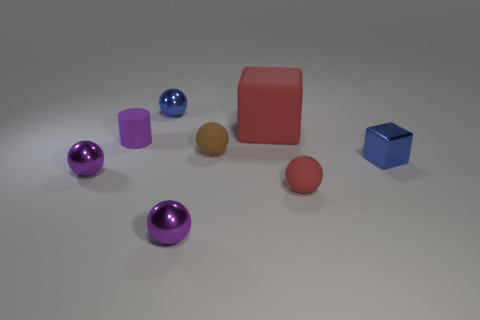What number of red rubber things are the same size as the brown matte thing?
Provide a succinct answer. 1. What material is the red object that is in front of the thing left of the cylinder?
Make the answer very short. Rubber. The purple metallic object that is right of the tiny matte thing that is to the left of the small blue thing left of the tiny metal block is what shape?
Give a very brief answer. Sphere. Do the tiny blue object that is to the left of the red ball and the red thing to the right of the large thing have the same shape?
Keep it short and to the point. Yes. How many other objects are there of the same material as the brown thing?
Provide a short and direct response. 3. What shape is the small brown object that is the same material as the tiny cylinder?
Provide a short and direct response. Sphere. Do the brown sphere and the purple matte cylinder have the same size?
Offer a terse response. Yes. There is a purple object right of the blue shiny thing that is on the left side of the red sphere; what is its size?
Offer a very short reply. Small. What shape is the metallic thing that is the same color as the tiny block?
Offer a terse response. Sphere. How many spheres are either gray objects or small purple metallic things?
Make the answer very short. 2. 